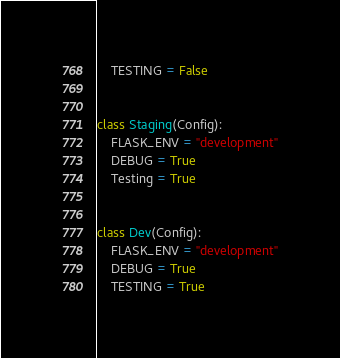<code> <loc_0><loc_0><loc_500><loc_500><_Python_>    TESTING = False


class Staging(Config):
    FLASK_ENV = "development"
    DEBUG = True
    Testing = True


class Dev(Config):
    FLASK_ENV = "development"
    DEBUG = True
    TESTING = True
</code> 